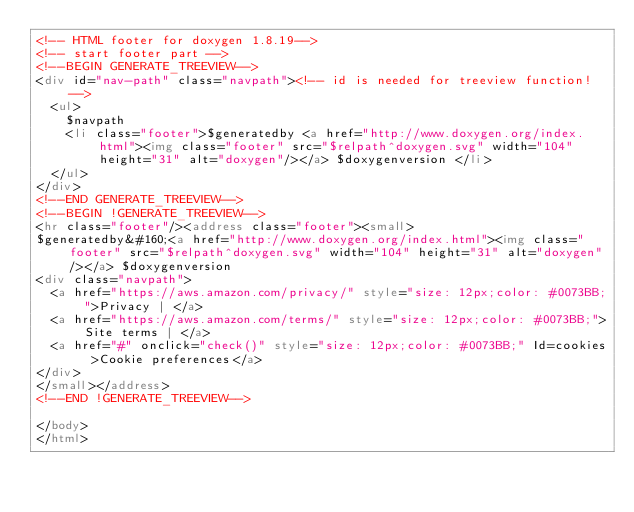Convert code to text. <code><loc_0><loc_0><loc_500><loc_500><_HTML_><!-- HTML footer for doxygen 1.8.19-->
<!-- start footer part -->
<!--BEGIN GENERATE_TREEVIEW-->
<div id="nav-path" class="navpath"><!-- id is needed for treeview function! -->
  <ul>
    $navpath
    <li class="footer">$generatedby <a href="http://www.doxygen.org/index.html"><img class="footer" src="$relpath^doxygen.svg" width="104" height="31" alt="doxygen"/></a> $doxygenversion </li>
  </ul>
</div>
<!--END GENERATE_TREEVIEW-->
<!--BEGIN !GENERATE_TREEVIEW-->
<hr class="footer"/><address class="footer"><small>
$generatedby&#160;<a href="http://www.doxygen.org/index.html"><img class="footer" src="$relpath^doxygen.svg" width="104" height="31" alt="doxygen"/></a> $doxygenversion
<div class="navpath">
  <a href="https://aws.amazon.com/privacy/" style="size: 12px;color: #0073BB;">Privacy | </a> 
  <a href="https://aws.amazon.com/terms/" style="size: 12px;color: #0073BB;">Site terms | </a> 
  <a href="#" onclick="check()" style="size: 12px;color: #0073BB;" Id=cookies >Cookie preferences</a>
</div>
</small></address>
<!--END !GENERATE_TREEVIEW-->

</body>
</html>
</code> 